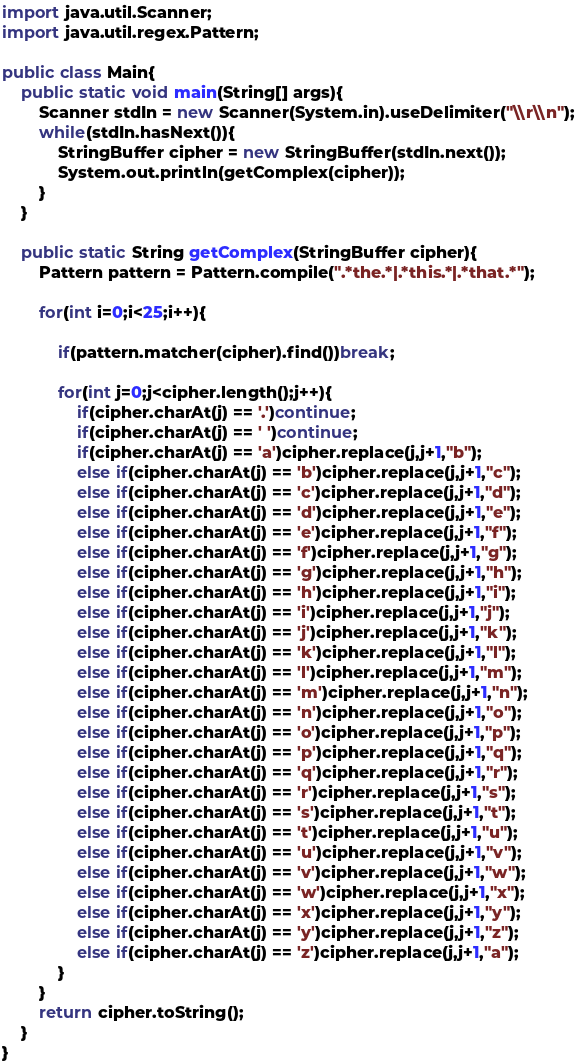Convert code to text. <code><loc_0><loc_0><loc_500><loc_500><_Java_>import java.util.Scanner;
import java.util.regex.Pattern;

public class Main{
	public static void main(String[] args){
		Scanner stdIn = new Scanner(System.in).useDelimiter("\\r\\n");
		while(stdIn.hasNext()){
			StringBuffer cipher = new StringBuffer(stdIn.next());
			System.out.println(getComplex(cipher));
		}
	}

	public static String getComplex(StringBuffer cipher){
		Pattern pattern = Pattern.compile(".*the.*|.*this.*|.*that.*");

		for(int i=0;i<25;i++){

			if(pattern.matcher(cipher).find())break;

			for(int j=0;j<cipher.length();j++){
				if(cipher.charAt(j) == '.')continue;
				if(cipher.charAt(j) == ' ')continue;
				if(cipher.charAt(j) == 'a')cipher.replace(j,j+1,"b");
				else if(cipher.charAt(j) == 'b')cipher.replace(j,j+1,"c");
				else if(cipher.charAt(j) == 'c')cipher.replace(j,j+1,"d");
				else if(cipher.charAt(j) == 'd')cipher.replace(j,j+1,"e");
				else if(cipher.charAt(j) == 'e')cipher.replace(j,j+1,"f");
				else if(cipher.charAt(j) == 'f')cipher.replace(j,j+1,"g");
				else if(cipher.charAt(j) == 'g')cipher.replace(j,j+1,"h");
				else if(cipher.charAt(j) == 'h')cipher.replace(j,j+1,"i");
				else if(cipher.charAt(j) == 'i')cipher.replace(j,j+1,"j");
				else if(cipher.charAt(j) == 'j')cipher.replace(j,j+1,"k");
				else if(cipher.charAt(j) == 'k')cipher.replace(j,j+1,"l");
				else if(cipher.charAt(j) == 'l')cipher.replace(j,j+1,"m");
				else if(cipher.charAt(j) == 'm')cipher.replace(j,j+1,"n");
				else if(cipher.charAt(j) == 'n')cipher.replace(j,j+1,"o");
				else if(cipher.charAt(j) == 'o')cipher.replace(j,j+1,"p");
				else if(cipher.charAt(j) == 'p')cipher.replace(j,j+1,"q");
				else if(cipher.charAt(j) == 'q')cipher.replace(j,j+1,"r");
				else if(cipher.charAt(j) == 'r')cipher.replace(j,j+1,"s");
				else if(cipher.charAt(j) == 's')cipher.replace(j,j+1,"t");
				else if(cipher.charAt(j) == 't')cipher.replace(j,j+1,"u");
				else if(cipher.charAt(j) == 'u')cipher.replace(j,j+1,"v");
				else if(cipher.charAt(j) == 'v')cipher.replace(j,j+1,"w");
				else if(cipher.charAt(j) == 'w')cipher.replace(j,j+1,"x");
				else if(cipher.charAt(j) == 'x')cipher.replace(j,j+1,"y");
				else if(cipher.charAt(j) == 'y')cipher.replace(j,j+1,"z");
				else if(cipher.charAt(j) == 'z')cipher.replace(j,j+1,"a");
			}
		}
		return cipher.toString();
	}
}</code> 